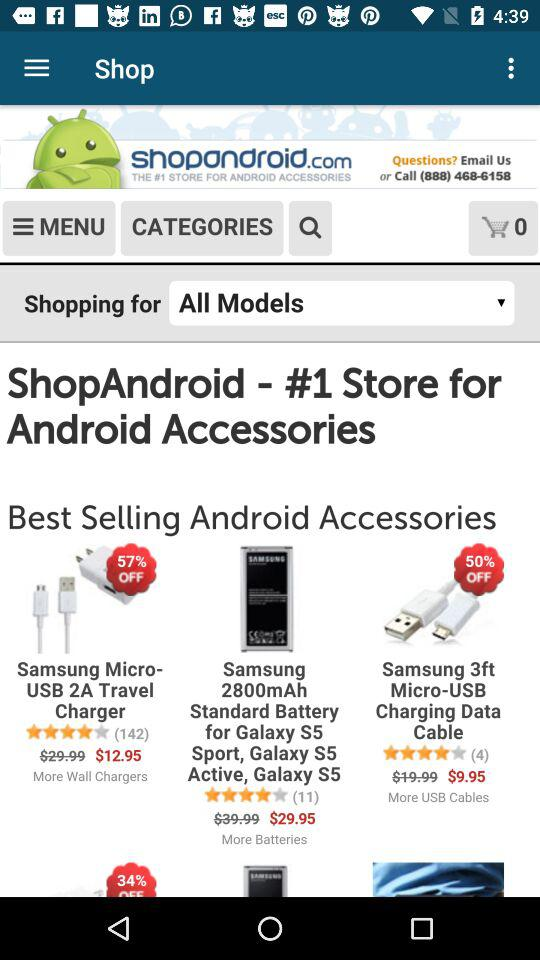What is the price of the "Samsung Micro-USB 2A Travel Charger" after discount? The price of the "Samsung Micro-USB 2A Travel Charger" after discount is $12.95. 